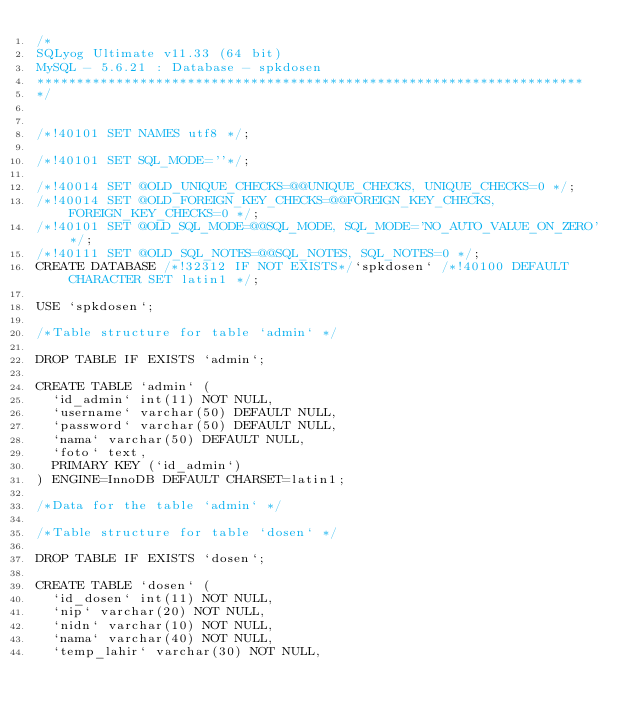Convert code to text. <code><loc_0><loc_0><loc_500><loc_500><_SQL_>/*
SQLyog Ultimate v11.33 (64 bit)
MySQL - 5.6.21 : Database - spkdosen
*********************************************************************
*/


/*!40101 SET NAMES utf8 */;

/*!40101 SET SQL_MODE=''*/;

/*!40014 SET @OLD_UNIQUE_CHECKS=@@UNIQUE_CHECKS, UNIQUE_CHECKS=0 */;
/*!40014 SET @OLD_FOREIGN_KEY_CHECKS=@@FOREIGN_KEY_CHECKS, FOREIGN_KEY_CHECKS=0 */;
/*!40101 SET @OLD_SQL_MODE=@@SQL_MODE, SQL_MODE='NO_AUTO_VALUE_ON_ZERO' */;
/*!40111 SET @OLD_SQL_NOTES=@@SQL_NOTES, SQL_NOTES=0 */;
CREATE DATABASE /*!32312 IF NOT EXISTS*/`spkdosen` /*!40100 DEFAULT CHARACTER SET latin1 */;

USE `spkdosen`;

/*Table structure for table `admin` */

DROP TABLE IF EXISTS `admin`;

CREATE TABLE `admin` (
  `id_admin` int(11) NOT NULL,
  `username` varchar(50) DEFAULT NULL,
  `password` varchar(50) DEFAULT NULL,
  `nama` varchar(50) DEFAULT NULL,
  `foto` text,
  PRIMARY KEY (`id_admin`)
) ENGINE=InnoDB DEFAULT CHARSET=latin1;

/*Data for the table `admin` */

/*Table structure for table `dosen` */

DROP TABLE IF EXISTS `dosen`;

CREATE TABLE `dosen` (
  `id_dosen` int(11) NOT NULL,
  `nip` varchar(20) NOT NULL,
  `nidn` varchar(10) NOT NULL,
  `nama` varchar(40) NOT NULL,
  `temp_lahir` varchar(30) NOT NULL,</code> 